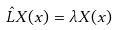<formula> <loc_0><loc_0><loc_500><loc_500>\hat { L } X ( x ) = \lambda X ( x )</formula> 